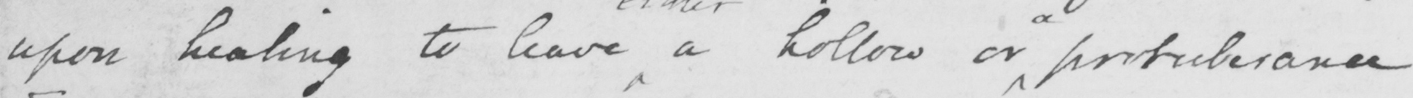Can you read and transcribe this handwriting? upon healing to leave a hollow or protuberance. 